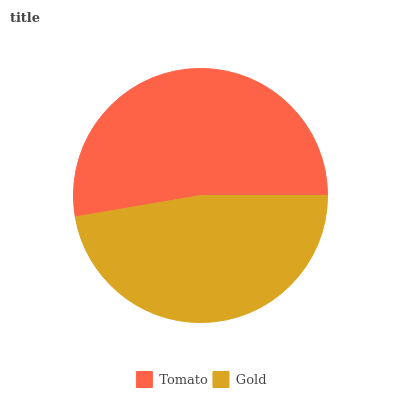Is Gold the minimum?
Answer yes or no. Yes. Is Tomato the maximum?
Answer yes or no. Yes. Is Gold the maximum?
Answer yes or no. No. Is Tomato greater than Gold?
Answer yes or no. Yes. Is Gold less than Tomato?
Answer yes or no. Yes. Is Gold greater than Tomato?
Answer yes or no. No. Is Tomato less than Gold?
Answer yes or no. No. Is Tomato the high median?
Answer yes or no. Yes. Is Gold the low median?
Answer yes or no. Yes. Is Gold the high median?
Answer yes or no. No. Is Tomato the low median?
Answer yes or no. No. 